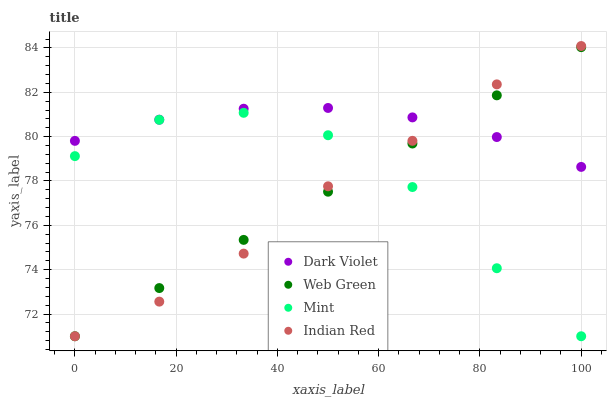Does Indian Red have the minimum area under the curve?
Answer yes or no. Yes. Does Dark Violet have the maximum area under the curve?
Answer yes or no. Yes. Does Mint have the minimum area under the curve?
Answer yes or no. No. Does Mint have the maximum area under the curve?
Answer yes or no. No. Is Web Green the smoothest?
Answer yes or no. Yes. Is Mint the roughest?
Answer yes or no. Yes. Is Mint the smoothest?
Answer yes or no. No. Is Web Green the roughest?
Answer yes or no. No. Does Indian Red have the lowest value?
Answer yes or no. Yes. Does Dark Violet have the lowest value?
Answer yes or no. No. Does Indian Red have the highest value?
Answer yes or no. Yes. Does Web Green have the highest value?
Answer yes or no. No. Is Mint less than Dark Violet?
Answer yes or no. Yes. Is Dark Violet greater than Mint?
Answer yes or no. Yes. Does Dark Violet intersect Indian Red?
Answer yes or no. Yes. Is Dark Violet less than Indian Red?
Answer yes or no. No. Is Dark Violet greater than Indian Red?
Answer yes or no. No. Does Mint intersect Dark Violet?
Answer yes or no. No. 